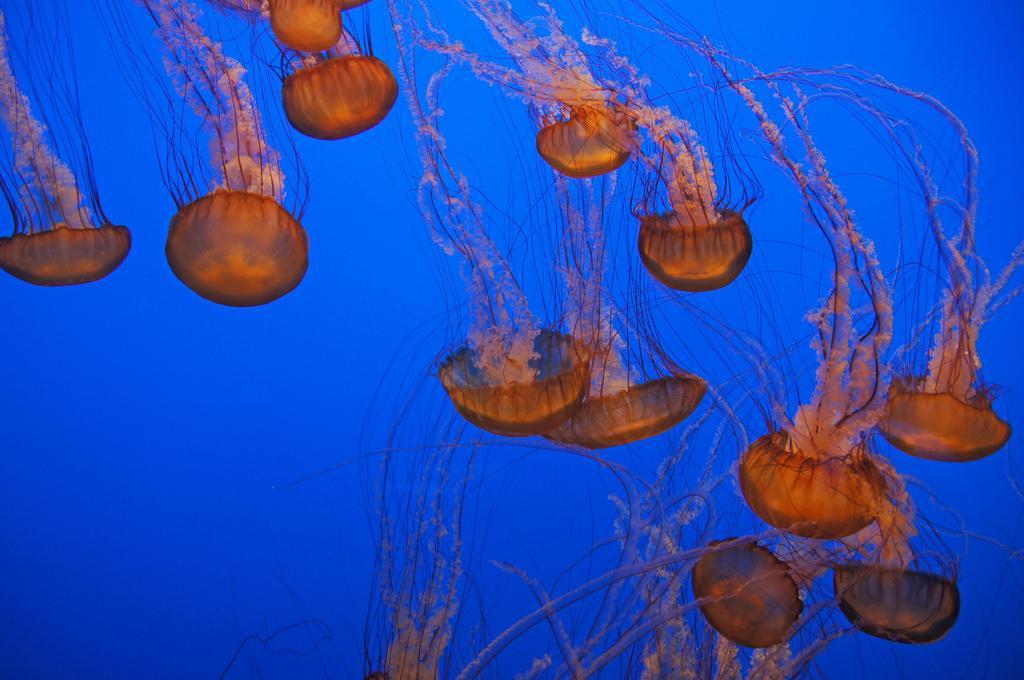Please provide a concise description of this image. In this image we can see some jelly fishes and the background is blue in color. 